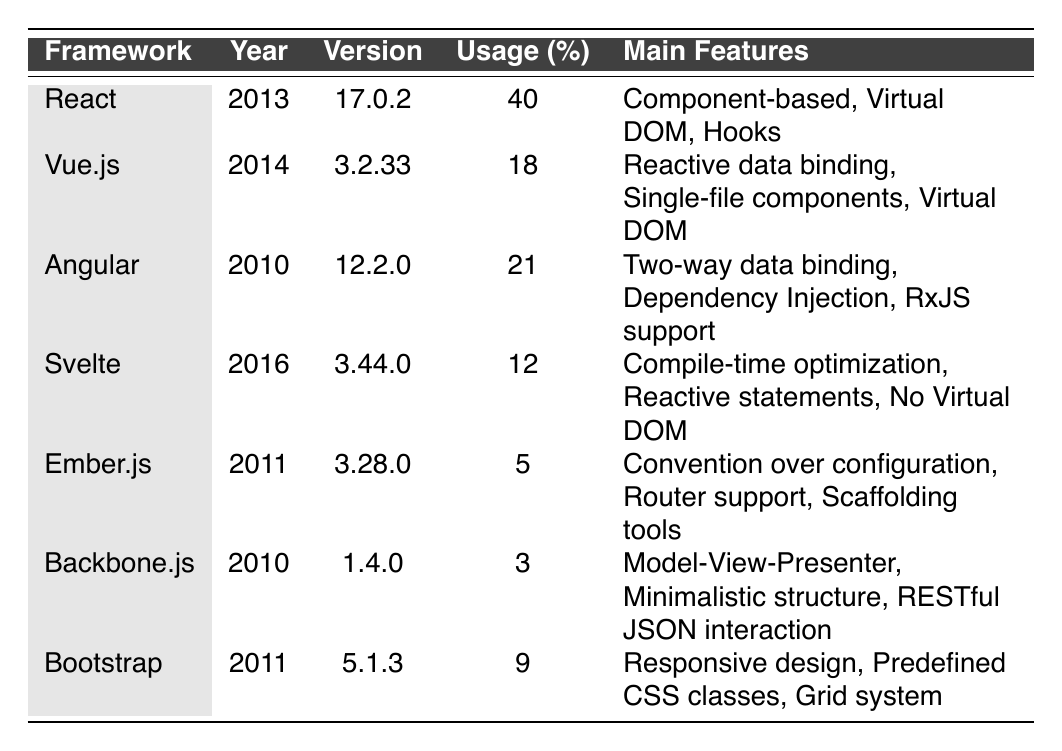What is the usage percentage of React? The usage percentage for React is stated directly in the table, which shows a usage of 40%.
Answer: 40% Which framework was introduced first: Angular or Bootstrap? From the table, Angular was introduced in 2010 and Bootstrap was introduced in 2011. Since 2010 comes before 2011, Angular was introduced first.
Answer: Angular What is the current version of Vue.js? The table lists the current version of Vue.js as 3.2.33.
Answer: 3.2.33 What are the main features of Svelte? The table enumerates the main features of Svelte as Compile-time optimization, Reactive statements, and No Virtual DOM.
Answer: Compile-time optimization, Reactive statements, No Virtual DOM Which two frameworks combined have a higher usage percentage than React? React has a usage percentage of 40%. Adding Vue.js (18%) and Angular (21%) gives 39%, which is less than React; however, if we add Angular (21%) and Svelte (12%), the total is 33%, still less than React. So no combination exceeds React's usage of 40%.
Answer: No combination How many frameworks have a usage percentage below 10%? The table shows three frameworks with usage percentages below 10%: Ember.js (5%), Backbone.js (3%), and Bootstrap (9%). Therefore, there are three frameworks below 10%.
Answer: 3 Is it true that all frameworks introduced after 2014 have a usage percentage over 10%? The frameworks introduced after 2014 are Svelte (12%) from 2016 and Vue.js (18%) from 2014, both of which have usage percentages over 10%. Thus, the statement is true.
Answer: Yes What is the average usage percentage of all the frameworks listed? The total usage percentages are (40 + 18 + 21 + 12 + 5 + 3 + 9) = 108. There are 7 frameworks, so the average is 108/7 = 15.43.
Answer: 15.43 Which framework has the highest usage? React has the highest usage at 40%, as stated in the table.
Answer: React What is the difference in usage percentage between Angular and Ember.js? Angular has a usage percentage of 21%, and Ember.js has 5%. The difference is 21 - 5 = 16.
Answer: 16 